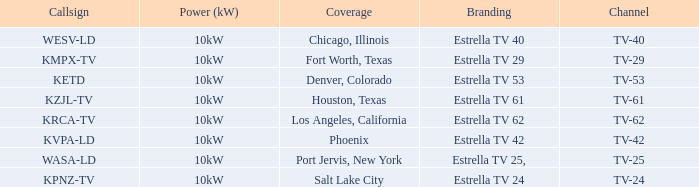Which city did kpnz-tv provide coverage for? Salt Lake City. 